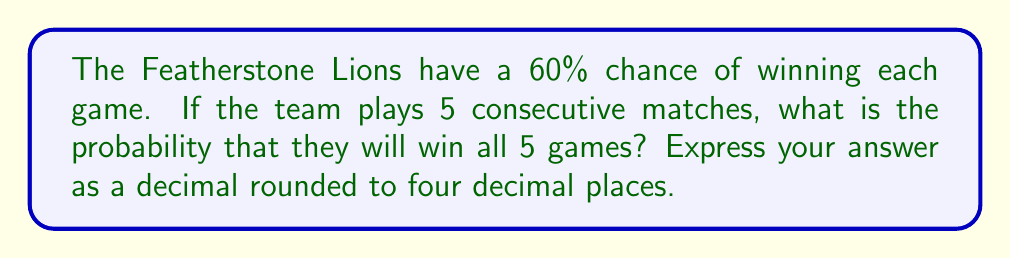Give your solution to this math problem. Let's approach this step-by-step:

1) The probability of winning a single game is 60% or 0.60.

2) We need to calculate the probability of winning 5 games in a row.

3) Since each game is independent, we can use the multiplication rule of probability. This is where exponents come in handy.

4) The probability of winning all 5 games is:

   $$(0.60)^5$$

5) Let's calculate this:
   
   $$(0.60)^5 = 0.60 \times 0.60 \times 0.60 \times 0.60 \times 0.60 = 0.07776$$

6) Rounding to four decimal places:

   $$0.07776 \approx 0.0778$$

Therefore, the probability of the Featherstone Lions winning all 5 consecutive games is approximately 0.0778 or 7.78%.
Answer: 0.0778 